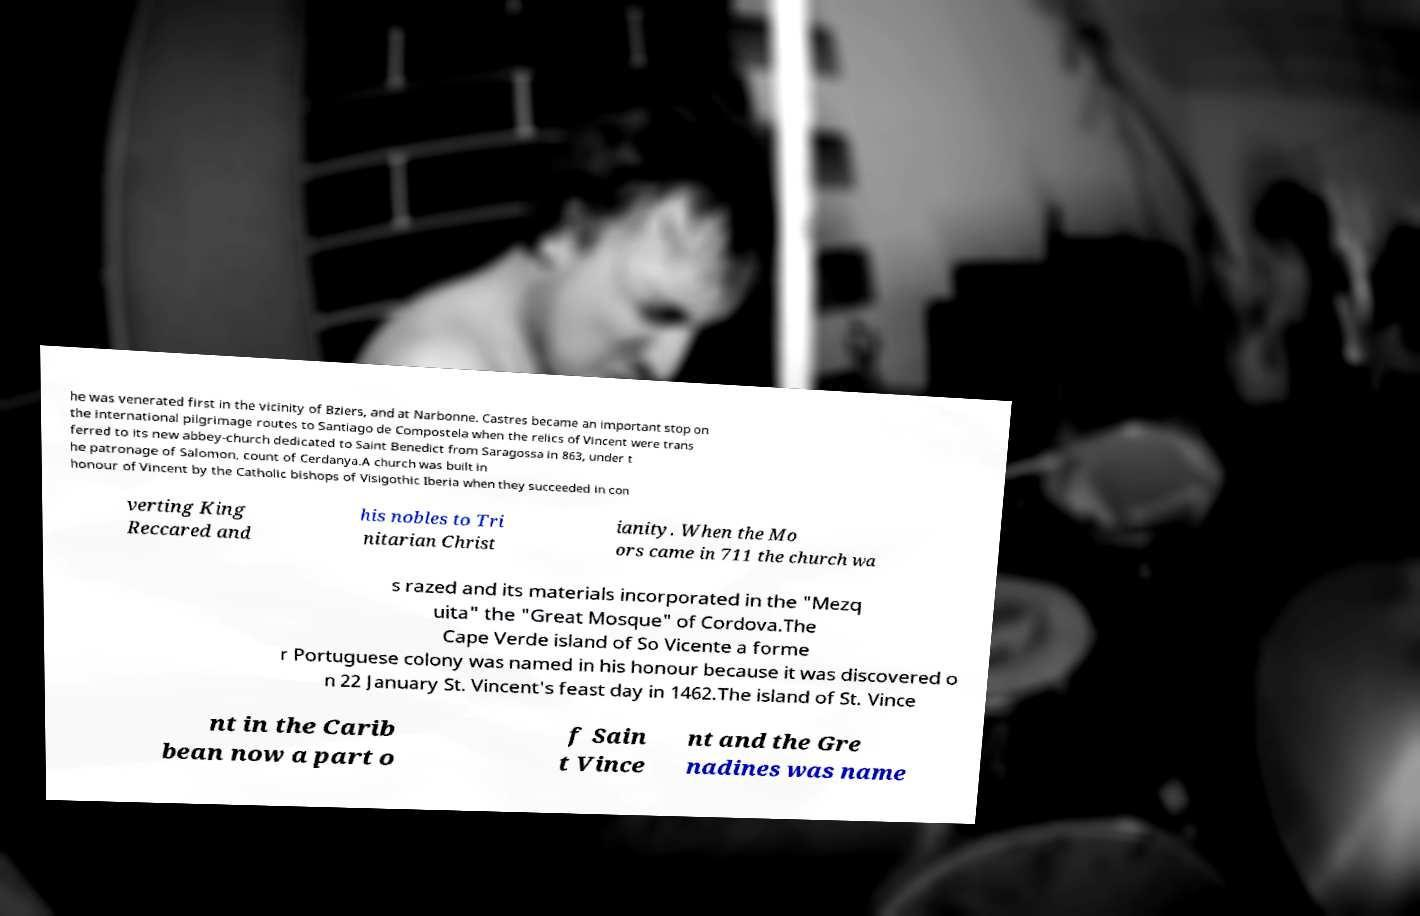Please identify and transcribe the text found in this image. he was venerated first in the vicinity of Bziers, and at Narbonne. Castres became an important stop on the international pilgrimage routes to Santiago de Compostela when the relics of Vincent were trans ferred to its new abbey-church dedicated to Saint Benedict from Saragossa in 863, under t he patronage of Salomon, count of Cerdanya.A church was built in honour of Vincent by the Catholic bishops of Visigothic Iberia when they succeeded in con verting King Reccared and his nobles to Tri nitarian Christ ianity. When the Mo ors came in 711 the church wa s razed and its materials incorporated in the "Mezq uita" the "Great Mosque" of Cordova.The Cape Verde island of So Vicente a forme r Portuguese colony was named in his honour because it was discovered o n 22 January St. Vincent's feast day in 1462.The island of St. Vince nt in the Carib bean now a part o f Sain t Vince nt and the Gre nadines was name 